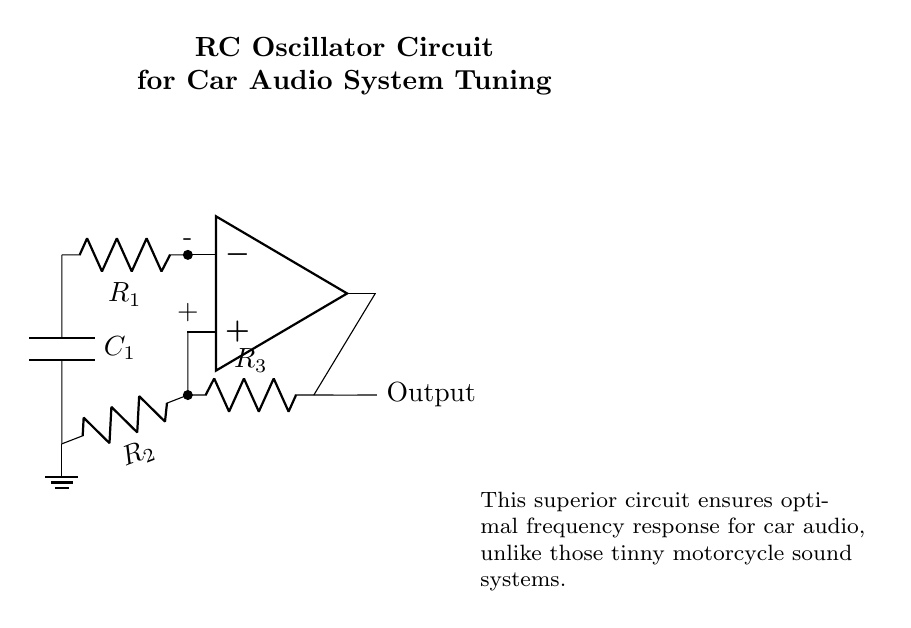What is the type of oscillator shown in the circuit? The circuit is an RC oscillator, which uses resistors and capacitors for generating oscillating signals.
Answer: RC oscillator What components are used in this circuit? The main components are an operational amplifier, resistors R1, R2, R3, and capacitor C1.
Answer: Operational amplifier, resistors R1, R2, R3, capacitor C1 What is the purpose of the operational amplifier in this circuit? The operational amplifier amplifies the voltage signal, essential for creating oscillations in the RC network.
Answer: Amplification How many resistors are present in the oscillator circuit? There are three resistors (R1, R2, R3) connected in various parts of the circuit.
Answer: Three What role does the capacitor play in this oscillator circuit? The capacitor determines the timing and frequency of the oscillation by charging and discharging.
Answer: Timing and frequency How does changing R1 affect the output frequency? Increasing R1 would increase the time constant of the circuit, resulting in a lower oscillation frequency and vice versa.
Answer: Lowers frequency Is this oscillator circuit suitable for audio applications? Yes, it is specifically designed for tuning car audio systems, implying suitability for audio outputs.
Answer: Yes 